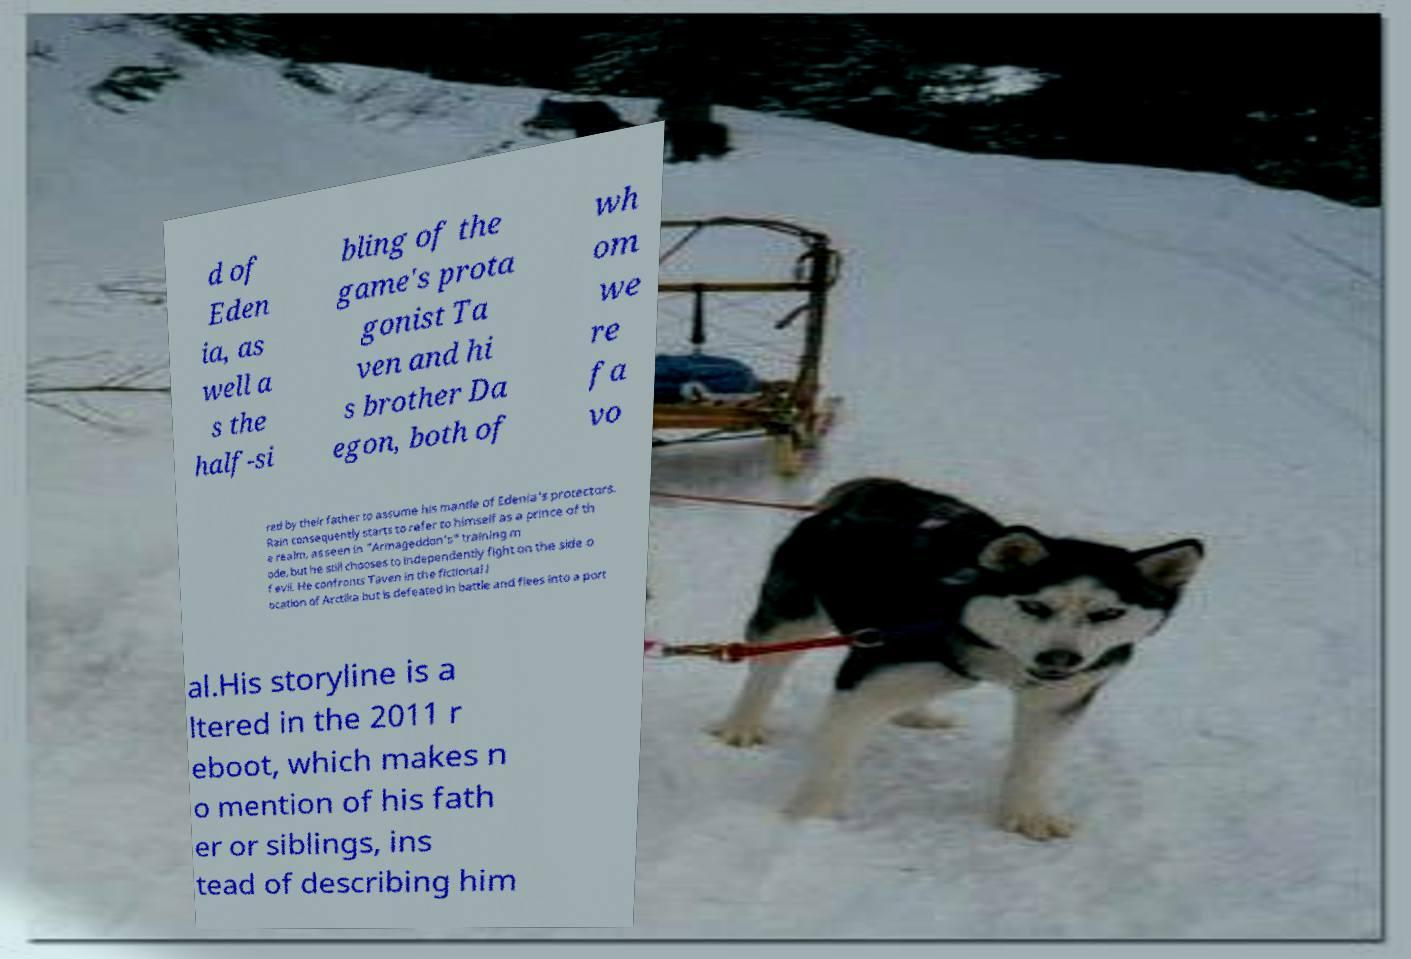There's text embedded in this image that I need extracted. Can you transcribe it verbatim? d of Eden ia, as well a s the half-si bling of the game's prota gonist Ta ven and hi s brother Da egon, both of wh om we re fa vo red by their father to assume his mantle of Edenia's protectors. Rain consequently starts to refer to himself as a prince of th e realm, as seen in "Armageddon's" training m ode, but he still chooses to independently fight on the side o f evil. He confronts Taven in the fictional l ocation of Arctika but is defeated in battle and flees into a port al.His storyline is a ltered in the 2011 r eboot, which makes n o mention of his fath er or siblings, ins tead of describing him 